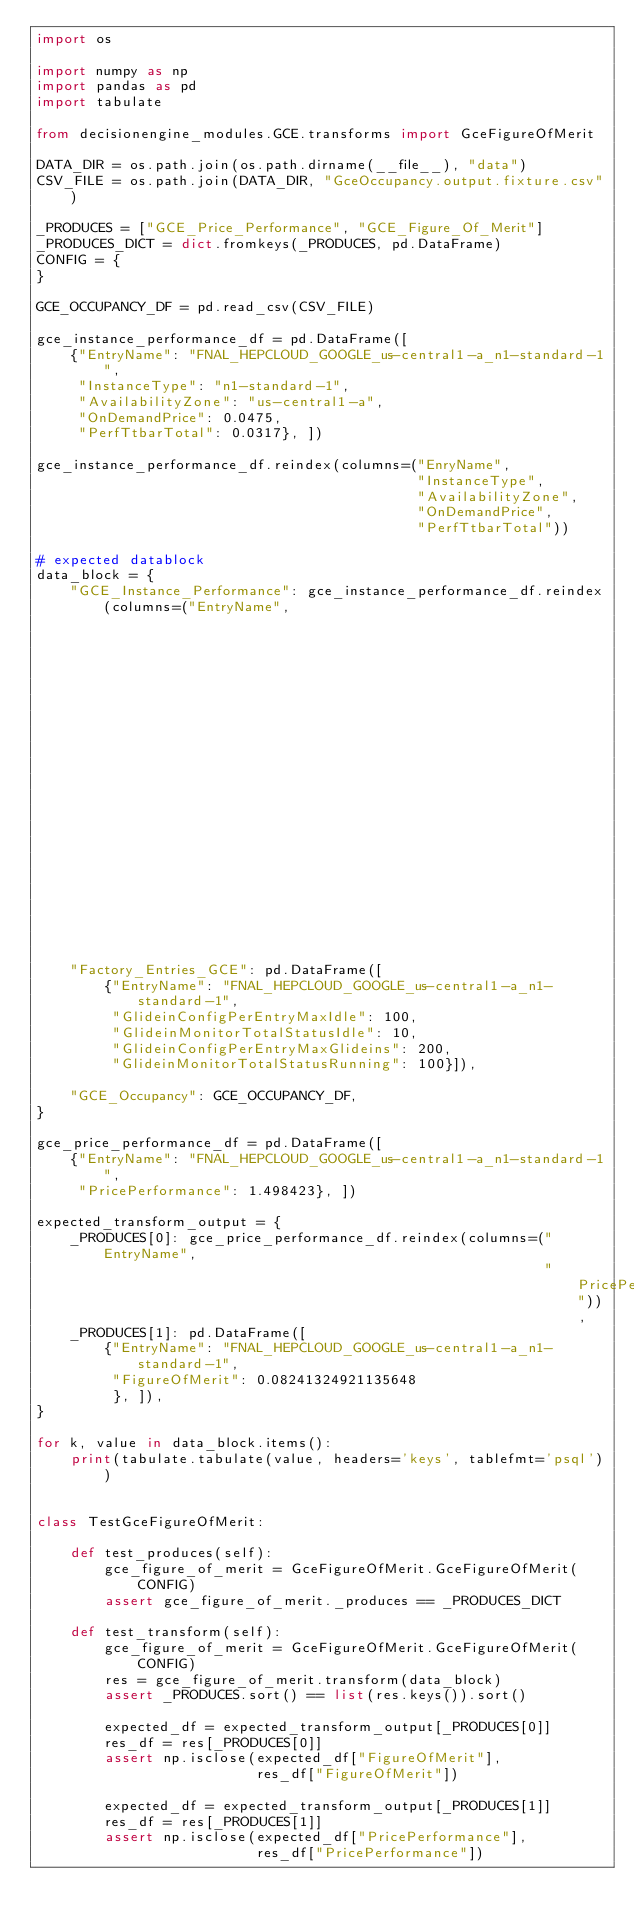<code> <loc_0><loc_0><loc_500><loc_500><_Python_>import os

import numpy as np
import pandas as pd
import tabulate

from decisionengine_modules.GCE.transforms import GceFigureOfMerit

DATA_DIR = os.path.join(os.path.dirname(__file__), "data")
CSV_FILE = os.path.join(DATA_DIR, "GceOccupancy.output.fixture.csv")

_PRODUCES = ["GCE_Price_Performance", "GCE_Figure_Of_Merit"]
_PRODUCES_DICT = dict.fromkeys(_PRODUCES, pd.DataFrame)
CONFIG = {
}

GCE_OCCUPANCY_DF = pd.read_csv(CSV_FILE)

gce_instance_performance_df = pd.DataFrame([
    {"EntryName": "FNAL_HEPCLOUD_GOOGLE_us-central1-a_n1-standard-1",
     "InstanceType": "n1-standard-1",
     "AvailabilityZone": "us-central1-a",
     "OnDemandPrice": 0.0475,
     "PerfTtbarTotal": 0.0317}, ])

gce_instance_performance_df.reindex(columns=("EnryName",
                                             "InstanceType",
                                             "AvailabilityZone",
                                             "OnDemandPrice",
                                             "PerfTtbarTotal"))

# expected datablock
data_block = {
    "GCE_Instance_Performance": gce_instance_performance_df.reindex(columns=("EntryName",
                                                                             "InstanceType",
                                                                             "AvailabilityZone",
                                                                             "OnDemandPrice",
                                                                             "PerfTtbarTotal")),
    "Factory_Entries_GCE": pd.DataFrame([
        {"EntryName": "FNAL_HEPCLOUD_GOOGLE_us-central1-a_n1-standard-1",
         "GlideinConfigPerEntryMaxIdle": 100,
         "GlideinMonitorTotalStatusIdle": 10,
         "GlideinConfigPerEntryMaxGlideins": 200,
         "GlideinMonitorTotalStatusRunning": 100}]),

    "GCE_Occupancy": GCE_OCCUPANCY_DF,
}

gce_price_performance_df = pd.DataFrame([
    {"EntryName": "FNAL_HEPCLOUD_GOOGLE_us-central1-a_n1-standard-1",
     "PricePerformance": 1.498423}, ])

expected_transform_output = {
    _PRODUCES[0]: gce_price_performance_df.reindex(columns=("EntryName",
                                                            "PricePerformance")),
    _PRODUCES[1]: pd.DataFrame([
        {"EntryName": "FNAL_HEPCLOUD_GOOGLE_us-central1-a_n1-standard-1",
         "FigureOfMerit": 0.08241324921135648
         }, ]),
}

for k, value in data_block.items():
    print(tabulate.tabulate(value, headers='keys', tablefmt='psql'))


class TestGceFigureOfMerit:

    def test_produces(self):
        gce_figure_of_merit = GceFigureOfMerit.GceFigureOfMerit(CONFIG)
        assert gce_figure_of_merit._produces == _PRODUCES_DICT

    def test_transform(self):
        gce_figure_of_merit = GceFigureOfMerit.GceFigureOfMerit(CONFIG)
        res = gce_figure_of_merit.transform(data_block)
        assert _PRODUCES.sort() == list(res.keys()).sort()

        expected_df = expected_transform_output[_PRODUCES[0]]
        res_df = res[_PRODUCES[0]]
        assert np.isclose(expected_df["FigureOfMerit"],
                          res_df["FigureOfMerit"])

        expected_df = expected_transform_output[_PRODUCES[1]]
        res_df = res[_PRODUCES[1]]
        assert np.isclose(expected_df["PricePerformance"],
                          res_df["PricePerformance"])
</code> 